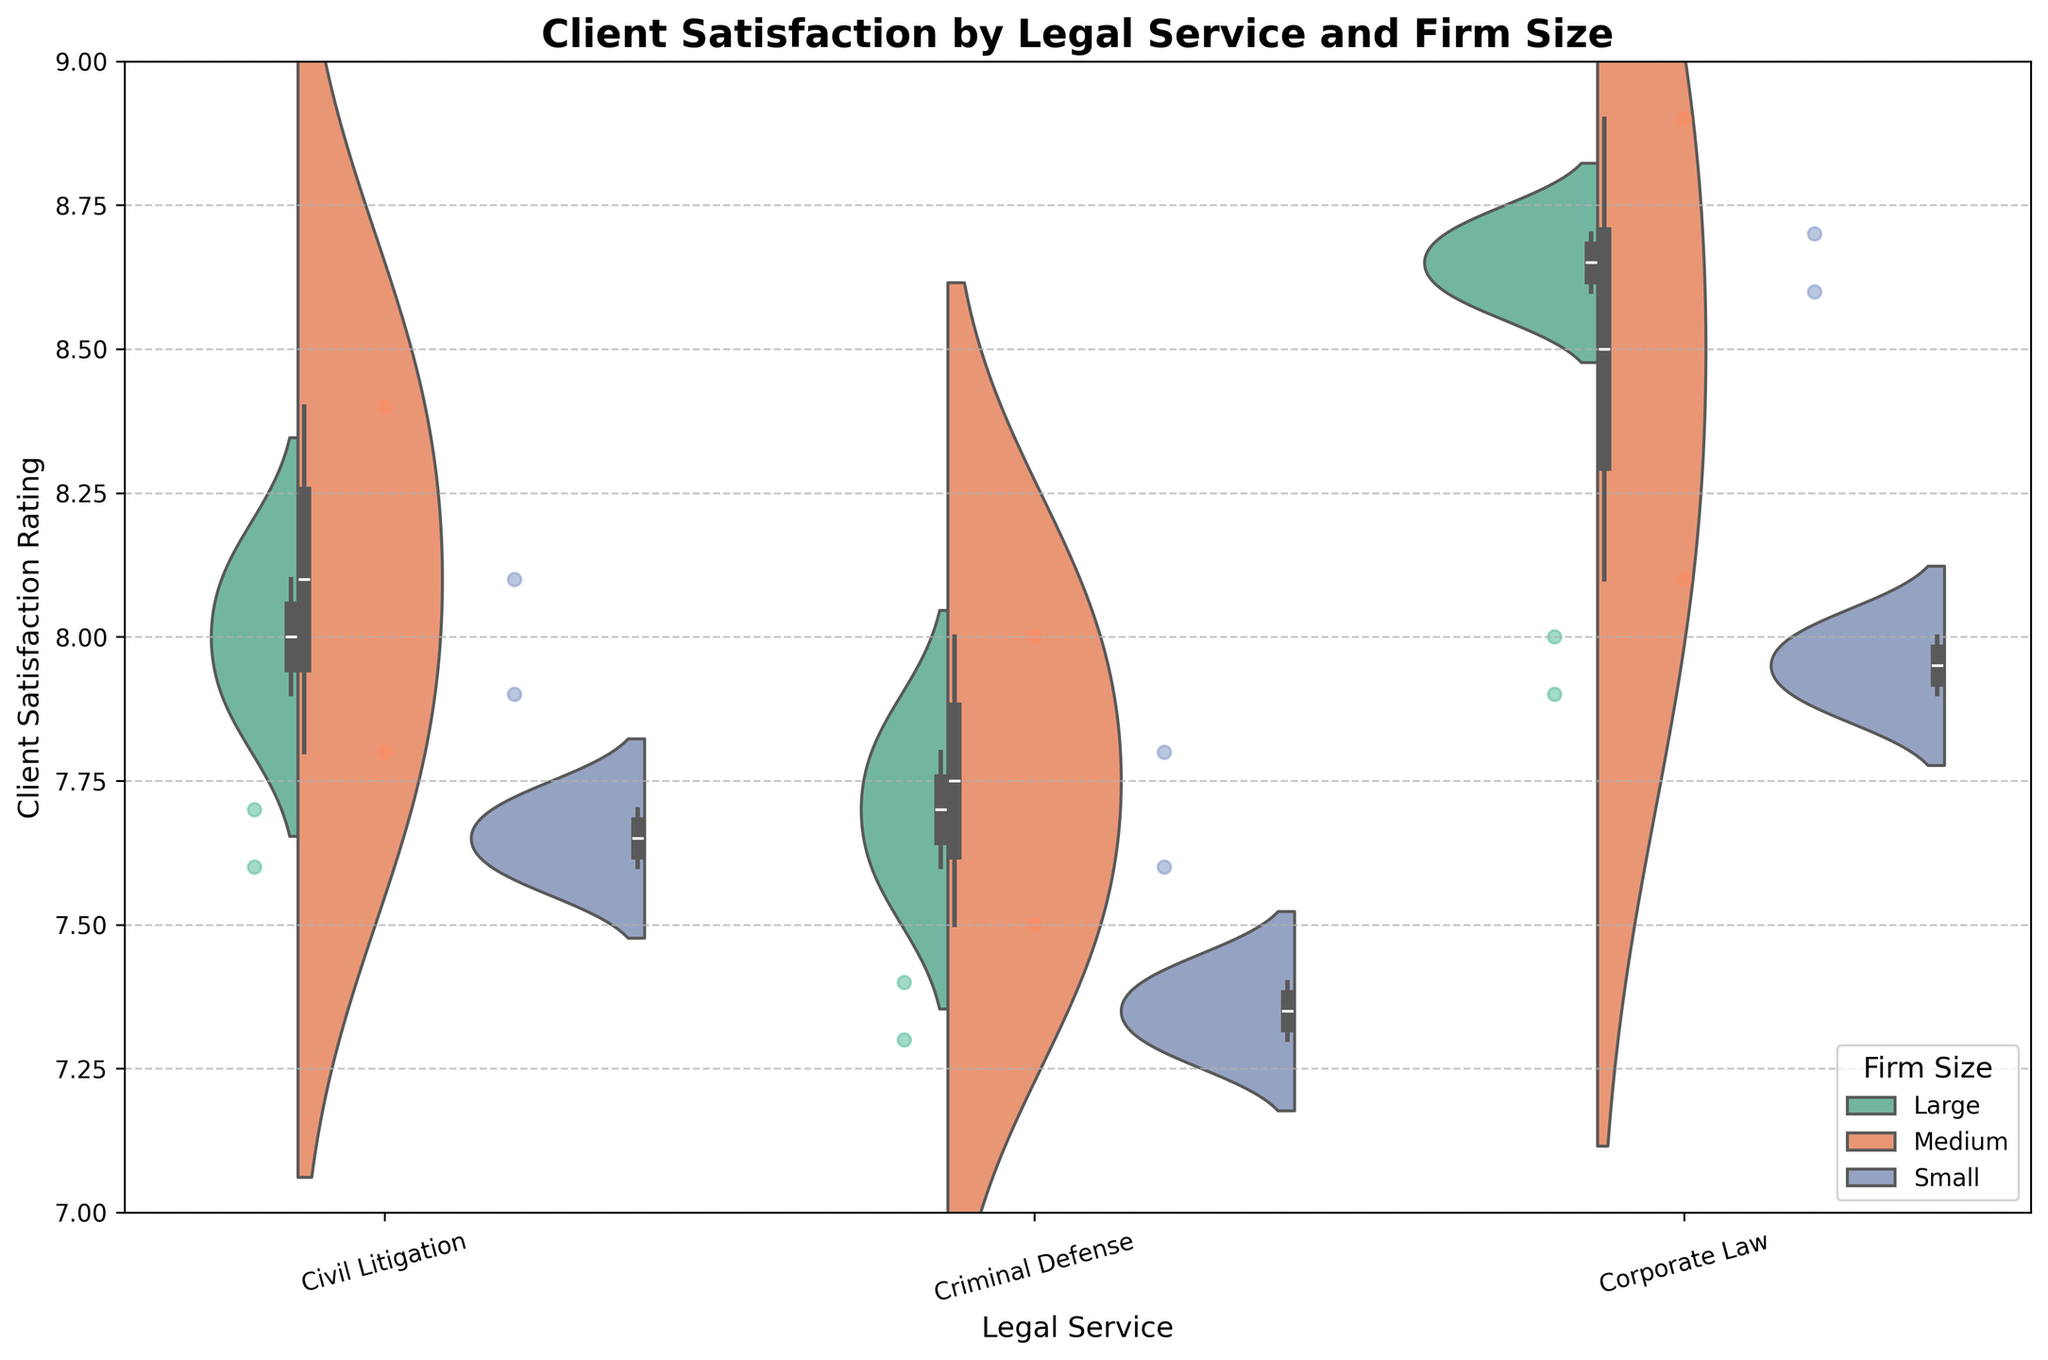What's the title of the plot? The title of the plot is displayed at the top and indicates the subject matter of the visualization. It reads, "Client Satisfaction by Legal Service and Firm Size."
Answer: Client Satisfaction by Legal Service and Firm Size How many different sizes of law firms are represented in the plot? In the legend on the plot's right side, three sizes of law firms are represented: Small, Medium, and Large.
Answer: 3 Which legal service has the highest median client satisfaction rating? By examining the box plot overlay on the violin charts, Corporate Law has the highest median, as its box plots are higher in the visualization compared to Civil Litigation and Criminal Defense.
Answer: Corporate Law Are the client satisfaction ratings for Medium-sized firms more consistent in Civil Litigation or Criminal Defense? Consistency can be inferred from the width of the violin plots. The violin plot for Medium-sized firms in Civil Litigation is narrower compared to Criminal Defense, indicating less spread in values.
Answer: Civil Litigation How do the client satisfaction ratings for Large firms compare between Criminal Defense and Corporate Law? For Large firms, the Criminal Defense ratings are lower and more variable compared to Corporate Law, as indicated by the position and spread of the violin and box plots.
Answer: Corporate Law > Criminal Defense Which size of the legal firm shows the most variance in Client Satisfaction for Corporate Law? The variance can be seen by looking at the width and spread of the violin plots. Medium firms show the most variance in Corporate Law as their violin plot is the widest.
Answer: Medium What is the approximate median client satisfaction rating for Small firms in Criminal Defense? By inspecting the position of the central line in the box plot within the violin plot for Small firms in Criminal Defense, the median is approximately at 7.35.
Answer: 7.35 Do any Legal Services have nearly overlapping client satisfaction distributions between different firm sizes? In Civil Litigation, the distributions for Small and Large firms almost overlap, indicating similar satisfaction ratings across these firm sizes.
Answer: Civil Litigation What is the overall trend observed for Client Satisfaction in Corporate Law across different firm sizes? Across all firm sizes (Small, Medium, Large), there is an upward trend in Client Satisfaction for Corporate Law, with Large firms having the highest median ratings.
Answer: Increasing with firm size Between Civil Litigation and Corporate Law, which shows a wider spread of client satisfaction ratings for Large firms? The wider spread can be deduced by examining the width of the corresponding violin plots. For Large firms, Civil Litigation shows a wider spread compared to Corporate Law.
Answer: Civil Litigation 